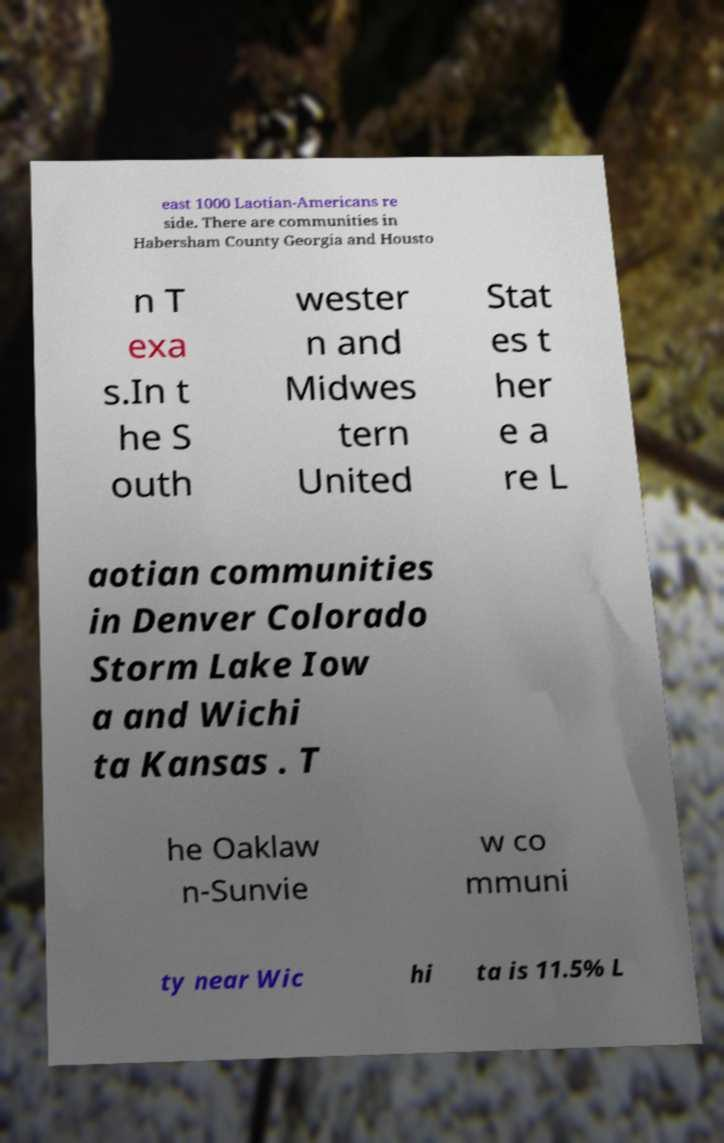Could you assist in decoding the text presented in this image and type it out clearly? east 1000 Laotian-Americans re side. There are communities in Habersham County Georgia and Housto n T exa s.In t he S outh wester n and Midwes tern United Stat es t her e a re L aotian communities in Denver Colorado Storm Lake Iow a and Wichi ta Kansas . T he Oaklaw n-Sunvie w co mmuni ty near Wic hi ta is 11.5% L 